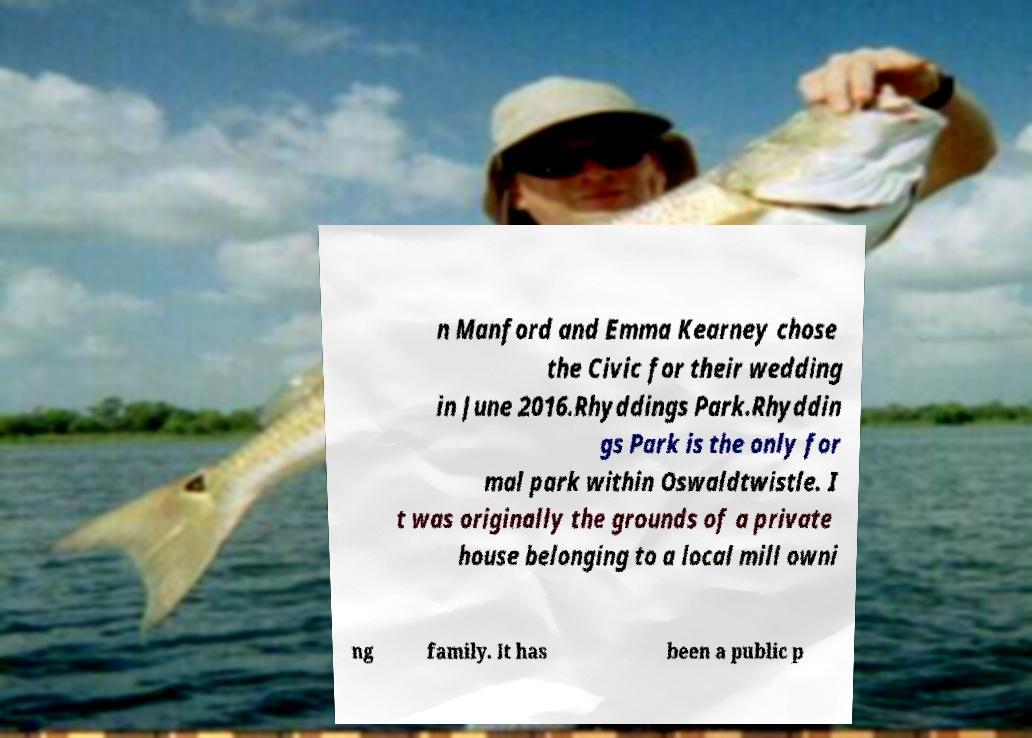For documentation purposes, I need the text within this image transcribed. Could you provide that? n Manford and Emma Kearney chose the Civic for their wedding in June 2016.Rhyddings Park.Rhyddin gs Park is the only for mal park within Oswaldtwistle. I t was originally the grounds of a private house belonging to a local mill owni ng family. It has been a public p 